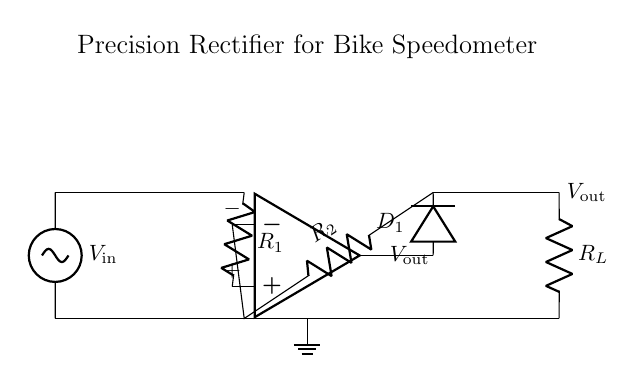What is the input voltage in the circuit? The input voltage is represented by the label \$V_{\text{in}}\$, which is applied to the circuit from the external source. The label indicates that it is the variable input voltage.
Answer: V in What is the role of the op-amp in this circuit? The operational amplifier (op-amp) is used to amplify the input signal and ensure that the output voltage can accurately reflect the input current through the configuration of a precision rectifier.
Answer: Amplifier What type of diodes are used in this circuit? The circuit uses a precision rectifier, which typically utilizes general-purpose or precision diodes to achieve accurate rectification.
Answer: Diode What is the purpose of resistor R1 in this circuit? Resistor R1 provides the necessary feedback to the op-amp, controlling gain and influencing how the input signal is rectified, determining how much of the input signal is allowed to affect the output.
Answer: Feedback resistor How does the precision rectifier differ from a standard rectifier? A precision rectifier can rectify signals smaller than the forward voltage drop of standard diodes, allowing for accurate rectification of weak signals, essential for current sensing in applications like bike computers.
Answer: Greater accuracy What will happen if R2 is removed from the circuit? If R2 is removed, the feedback loop will be disrupted, and the op-amp will not function correctly, leading to inaccurate rectification and potential distortion in the output voltage signal.
Answer: Distortion What is the output voltage in relation to the input voltage? The output voltage \$V_{\text{out}}\$ is essentially a rectified and amplified version of the input voltage \$V_{\text{in}}\$ with the effects of the op-amp and diode influencing its final value.
Answer: Rectified voltage 